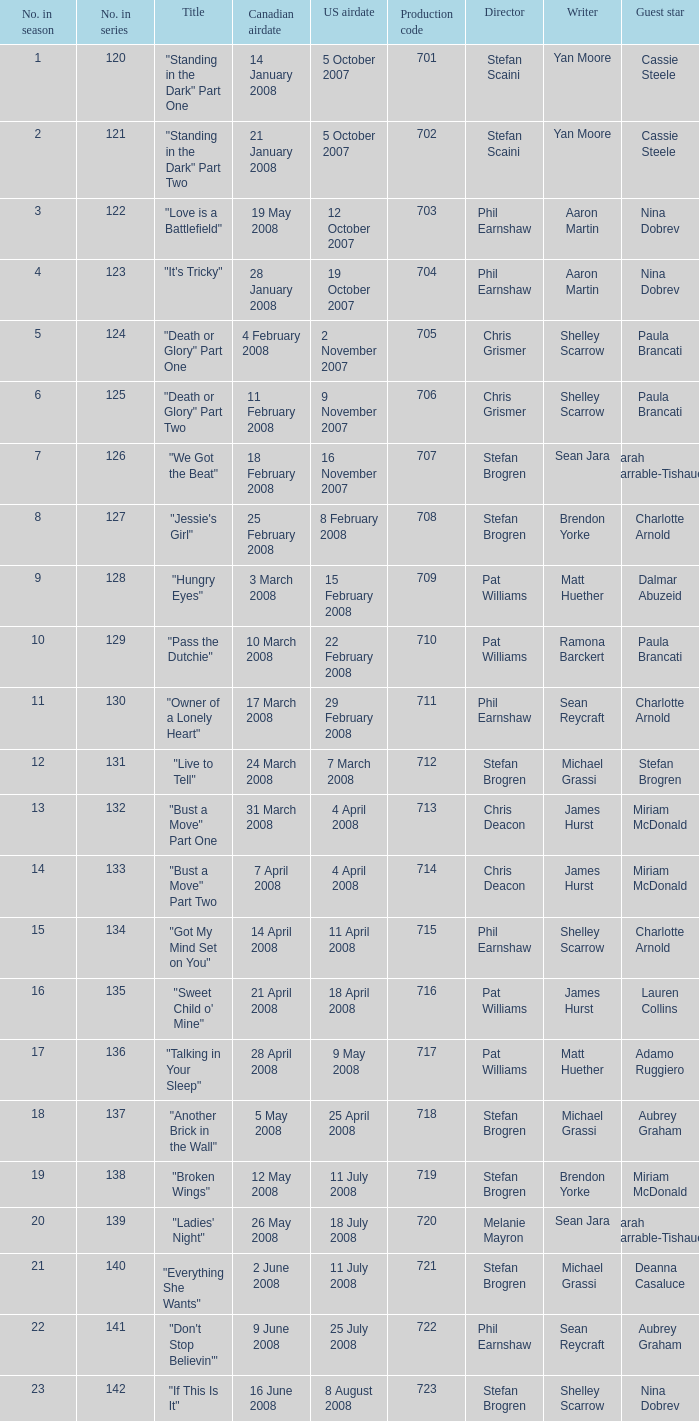The U.S. airdate of 8 august 2008 also had canadian airdates of what? 16 June 2008. 